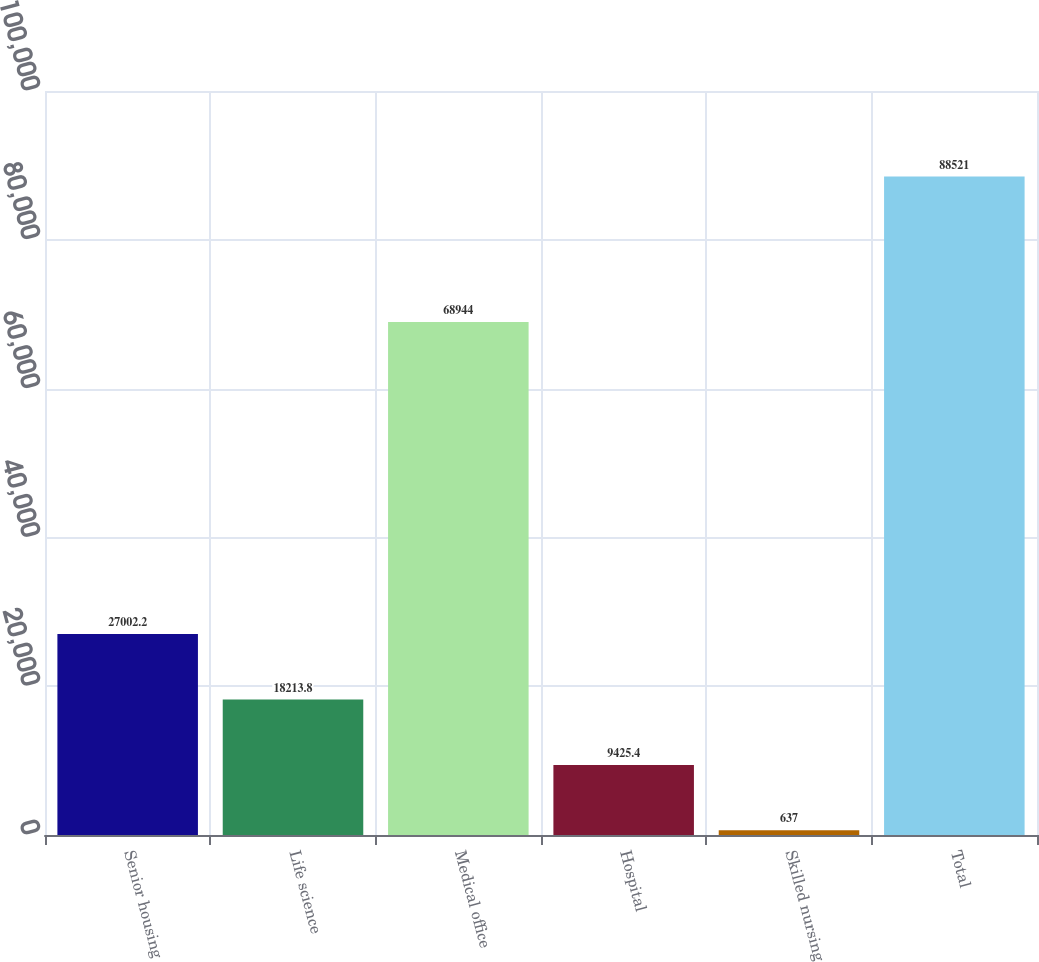<chart> <loc_0><loc_0><loc_500><loc_500><bar_chart><fcel>Senior housing<fcel>Life science<fcel>Medical office<fcel>Hospital<fcel>Skilled nursing<fcel>Total<nl><fcel>27002.2<fcel>18213.8<fcel>68944<fcel>9425.4<fcel>637<fcel>88521<nl></chart> 